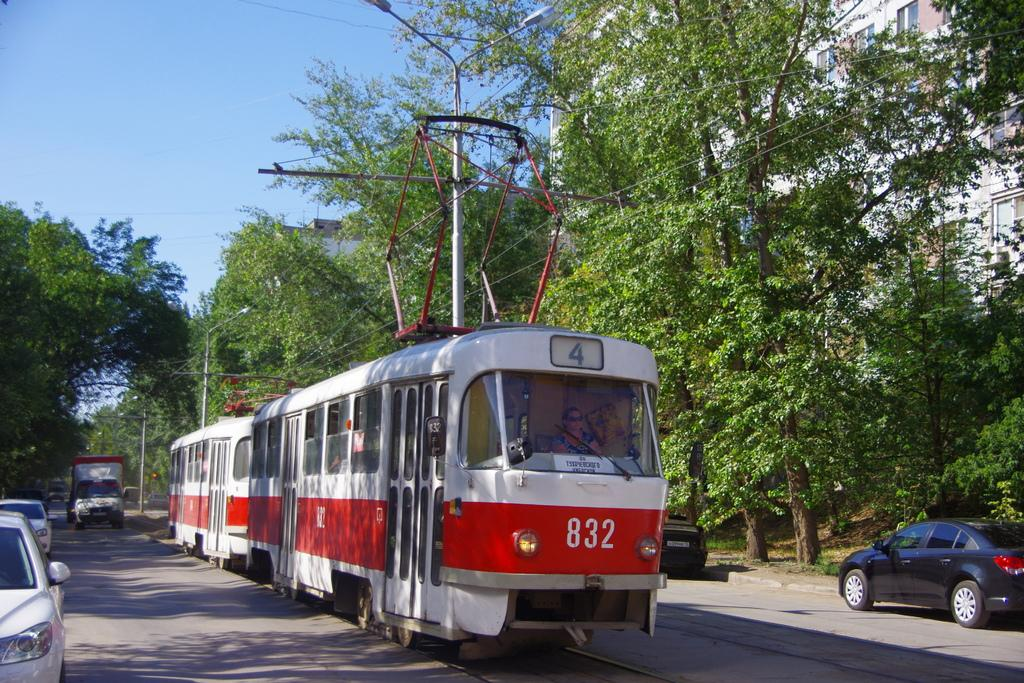What can be seen on the road in the image? There are vehicles on the road in the image. What else is present on the road besides vehicles? There are poles on the road. What is suspended above the vehicles and poles? There are electric lines above the vehicles. What can be seen in the distance behind the vehicles and poles? There are buildings in the background. What is the color of the sky in the image? The sky is blue in the image. How many straws are being used by the boys in the image? There are no boys or straws present in the image. What type of tooth is visible in the image? There is no tooth visible in the image. 